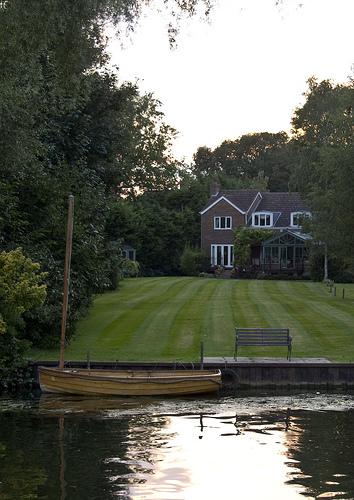Is the boat in a river or lake?
Answer briefly. Lake. Is there anyone on the bench?
Answer briefly. No. What type of boat is in the water?
Keep it brief. Canoe. How many lines is on the grass?
Write a very short answer. 10. 